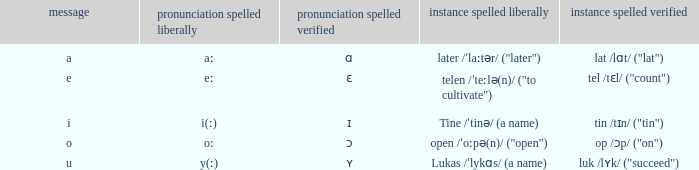What is Letter, when Example Spelled Checked is "tin /tɪn/ ("tin")"? I. 